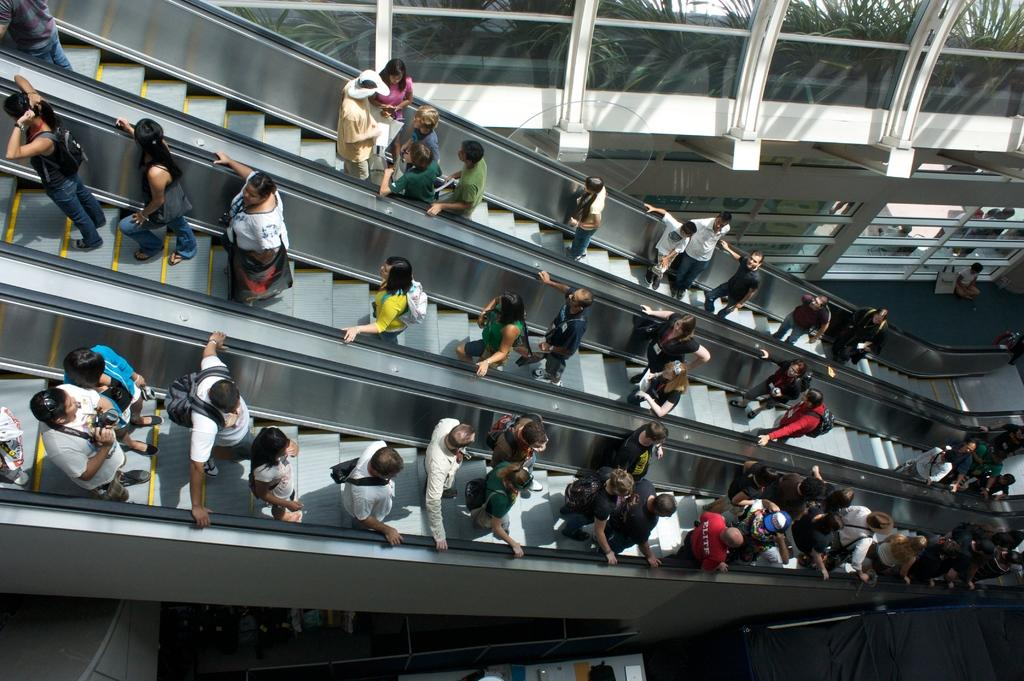What type of transportation is present in the image? There are escalators in the image. Are there any people using the escalators? Yes, there are people on the escalators. What can be seen in the background of the image? In the background, there are planets visible through the glass. What type of shoes are the people wearing on the escalators? There is no information about the shoes the people are wearing in the image. 